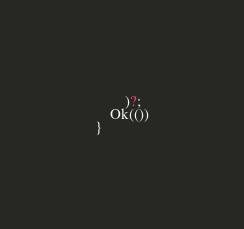Convert code to text. <code><loc_0><loc_0><loc_500><loc_500><_Rust_>        )?;
    Ok(())
}
</code> 